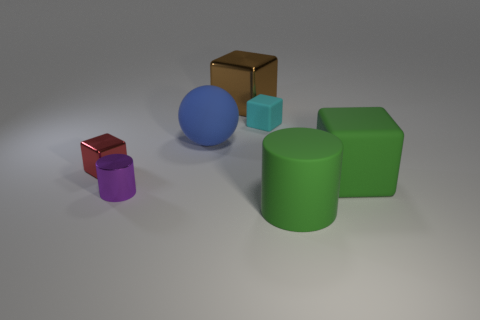Subtract all brown cylinders. Subtract all red blocks. How many cylinders are left? 2 Add 2 tiny purple things. How many objects exist? 9 Subtract all spheres. How many objects are left? 6 Subtract all metal cylinders. Subtract all small objects. How many objects are left? 3 Add 6 brown shiny cubes. How many brown shiny cubes are left? 7 Add 4 small purple metal objects. How many small purple metal objects exist? 5 Subtract 0 yellow cubes. How many objects are left? 7 